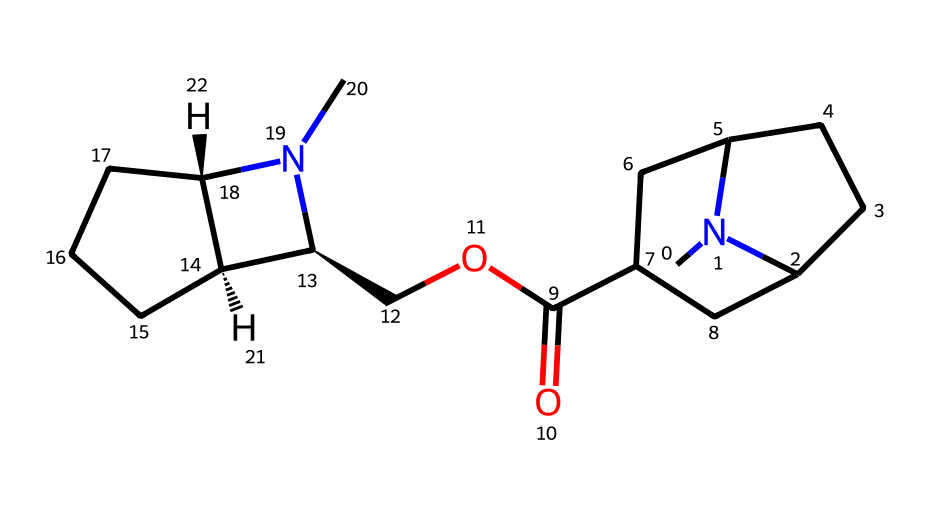What is the primary functional group present in cocaine? The structure contains an ester (seen by the carbonyl group adjacent to an oxygen atom), indicating that an ester functional group is present.
Answer: ester How many nitrogen atoms are in the cocaine structure? By examining the SMILES representation, we can find two nitrogen atoms (represented by 'N') in the structure.
Answer: 2 What type of drug is cocaine classified as? Cocaine is classified as a stimulant drug due to its effects on the central nervous system, characterized by its specific structural features like the presence of a tropane ring.
Answer: stimulant What is the total number of carbon atoms in cocaine? By counting the 'C' symbols in the SMILES notation, there are a total of 17 carbon atoms in the cocaine molecule.
Answer: 17 Which part of the chemical structure contributes to its alkaloid classification? The presence of nitrogen atoms along with a bicyclic structure contributes to the classification of cocaine as an alkaloid.
Answer: nitrogen atoms What type of rings are present in the cocaine structure? The structure of cocaine contains two fused ring systems, which can be identified as a bicyclic framework, involving a six-membered and a five-membered ring.
Answer: bicyclic What does the 'O' in the SMILES indicate about cocaine's solubility? The presence of the 'O' (oxygen in the ester) suggests that cocaine has some degree of hydrophilicity, which contributes to its solubility in organic solvents.
Answer: hydrophilicity 